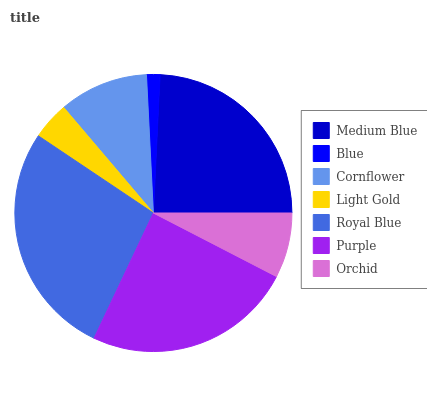Is Blue the minimum?
Answer yes or no. Yes. Is Royal Blue the maximum?
Answer yes or no. Yes. Is Cornflower the minimum?
Answer yes or no. No. Is Cornflower the maximum?
Answer yes or no. No. Is Cornflower greater than Blue?
Answer yes or no. Yes. Is Blue less than Cornflower?
Answer yes or no. Yes. Is Blue greater than Cornflower?
Answer yes or no. No. Is Cornflower less than Blue?
Answer yes or no. No. Is Cornflower the high median?
Answer yes or no. Yes. Is Cornflower the low median?
Answer yes or no. Yes. Is Medium Blue the high median?
Answer yes or no. No. Is Blue the low median?
Answer yes or no. No. 